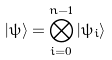<formula> <loc_0><loc_0><loc_500><loc_500>| \psi \rangle = \bigotimes _ { i = 0 } ^ { n - 1 } | \psi _ { i } \rangle</formula> 